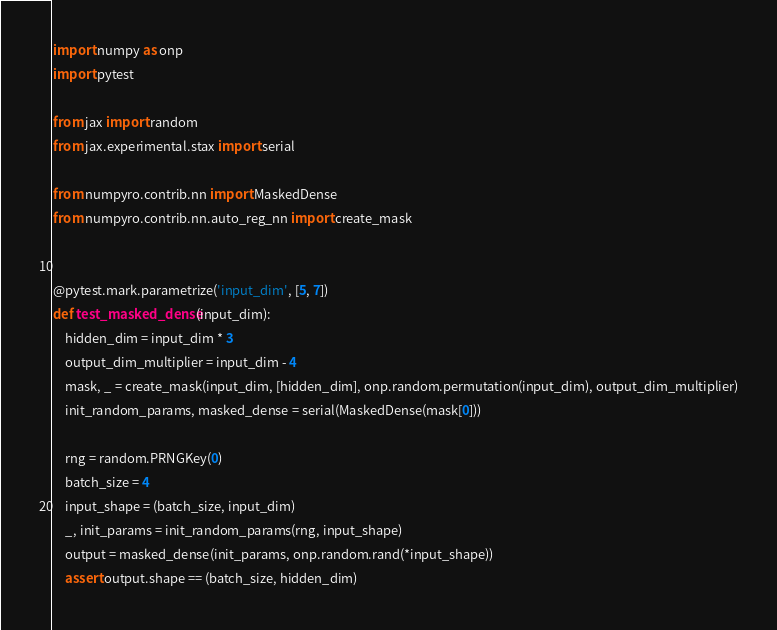<code> <loc_0><loc_0><loc_500><loc_500><_Python_>import numpy as onp
import pytest

from jax import random
from jax.experimental.stax import serial

from numpyro.contrib.nn import MaskedDense
from numpyro.contrib.nn.auto_reg_nn import create_mask


@pytest.mark.parametrize('input_dim', [5, 7])
def test_masked_dense(input_dim):
    hidden_dim = input_dim * 3
    output_dim_multiplier = input_dim - 4
    mask, _ = create_mask(input_dim, [hidden_dim], onp.random.permutation(input_dim), output_dim_multiplier)
    init_random_params, masked_dense = serial(MaskedDense(mask[0]))

    rng = random.PRNGKey(0)
    batch_size = 4
    input_shape = (batch_size, input_dim)
    _, init_params = init_random_params(rng, input_shape)
    output = masked_dense(init_params, onp.random.rand(*input_shape))
    assert output.shape == (batch_size, hidden_dim)
</code> 